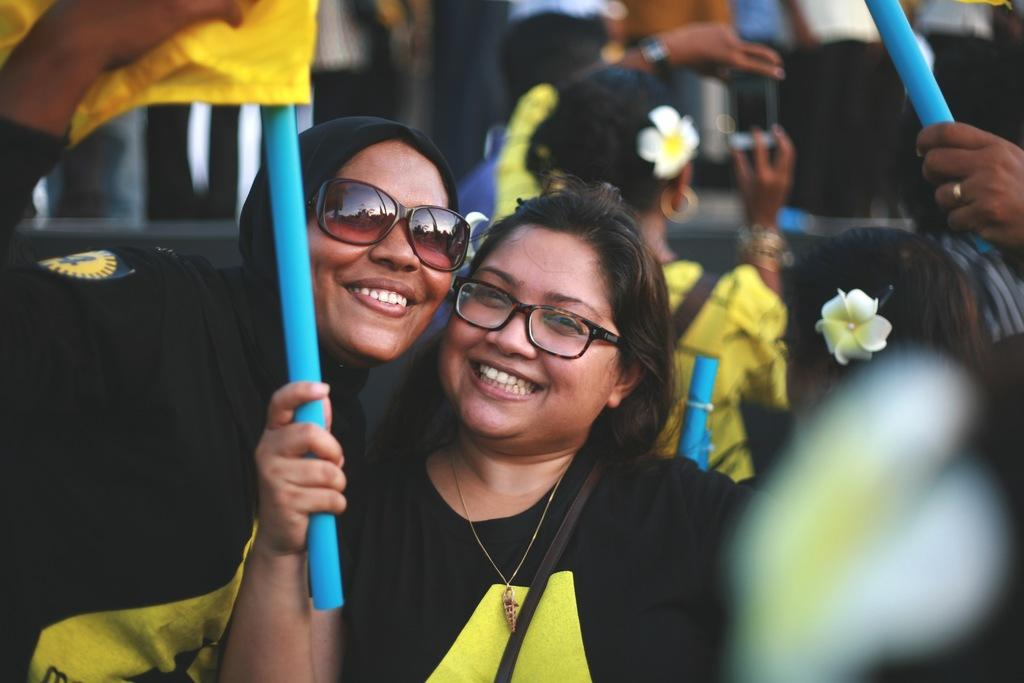Who or what is present in the image? There are people in the image. What are the people holding in their hands? The people are holding flags in their hands. How many roses can be seen on the people's clothing in the image? There are no roses visible on the people's clothing in the image. 